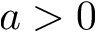<formula> <loc_0><loc_0><loc_500><loc_500>a > 0</formula> 